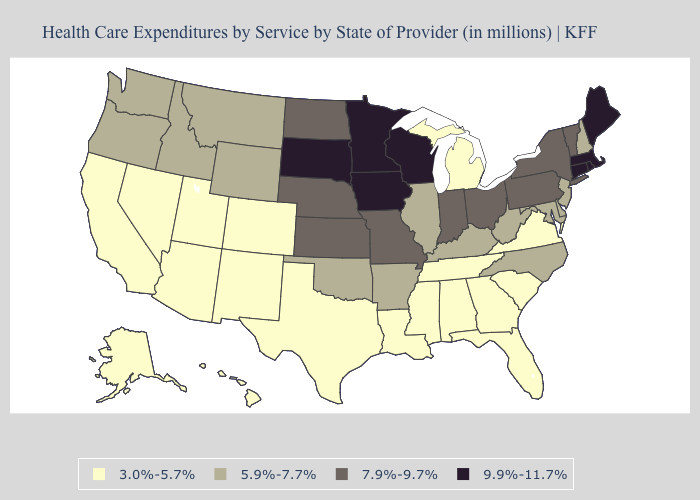Does Pennsylvania have the lowest value in the USA?
Short answer required. No. What is the value of Georgia?
Concise answer only. 3.0%-5.7%. Among the states that border Kentucky , does Virginia have the lowest value?
Write a very short answer. Yes. Name the states that have a value in the range 5.9%-7.7%?
Concise answer only. Arkansas, Delaware, Idaho, Illinois, Kentucky, Maryland, Montana, New Hampshire, New Jersey, North Carolina, Oklahoma, Oregon, Washington, West Virginia, Wyoming. Name the states that have a value in the range 5.9%-7.7%?
Keep it brief. Arkansas, Delaware, Idaho, Illinois, Kentucky, Maryland, Montana, New Hampshire, New Jersey, North Carolina, Oklahoma, Oregon, Washington, West Virginia, Wyoming. Which states have the highest value in the USA?
Concise answer only. Connecticut, Iowa, Maine, Massachusetts, Minnesota, Rhode Island, South Dakota, Wisconsin. Which states have the lowest value in the MidWest?
Concise answer only. Michigan. Does the first symbol in the legend represent the smallest category?
Quick response, please. Yes. What is the lowest value in the USA?
Answer briefly. 3.0%-5.7%. Is the legend a continuous bar?
Give a very brief answer. No. What is the highest value in the USA?
Keep it brief. 9.9%-11.7%. Does Washington have the lowest value in the West?
Quick response, please. No. What is the highest value in states that border Maryland?
Write a very short answer. 7.9%-9.7%. Name the states that have a value in the range 5.9%-7.7%?
Be succinct. Arkansas, Delaware, Idaho, Illinois, Kentucky, Maryland, Montana, New Hampshire, New Jersey, North Carolina, Oklahoma, Oregon, Washington, West Virginia, Wyoming. Does the map have missing data?
Write a very short answer. No. 